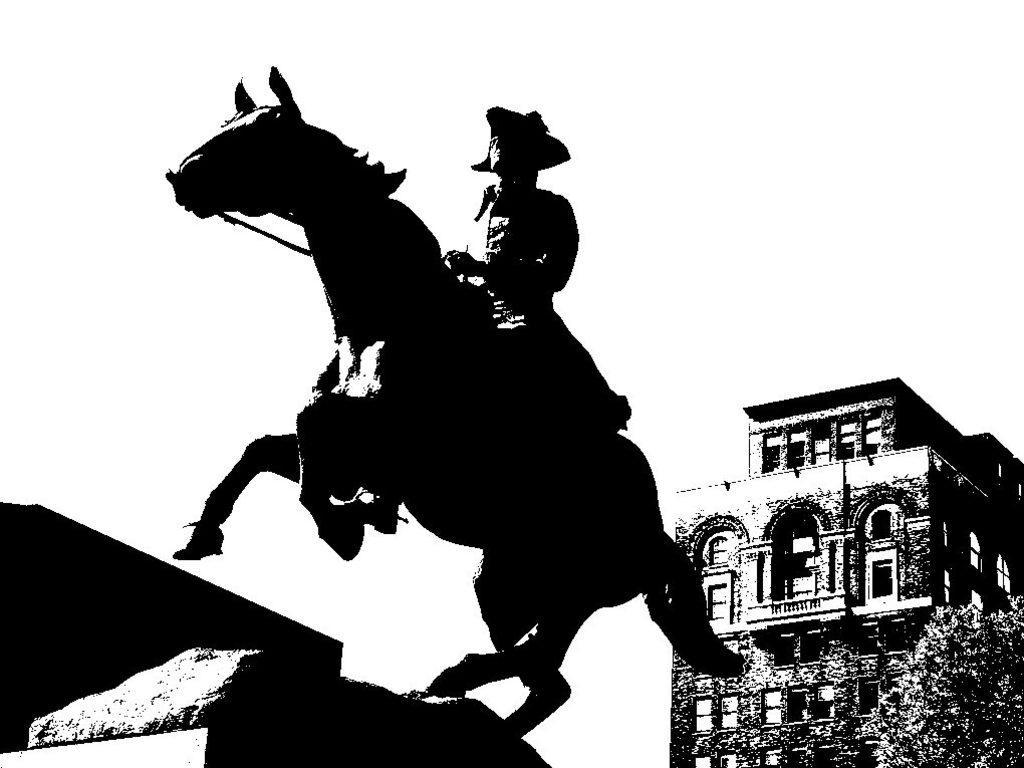Describe this image in one or two sentences. This is a monochrome image of person riding horse, behind him there is a building and plants. 